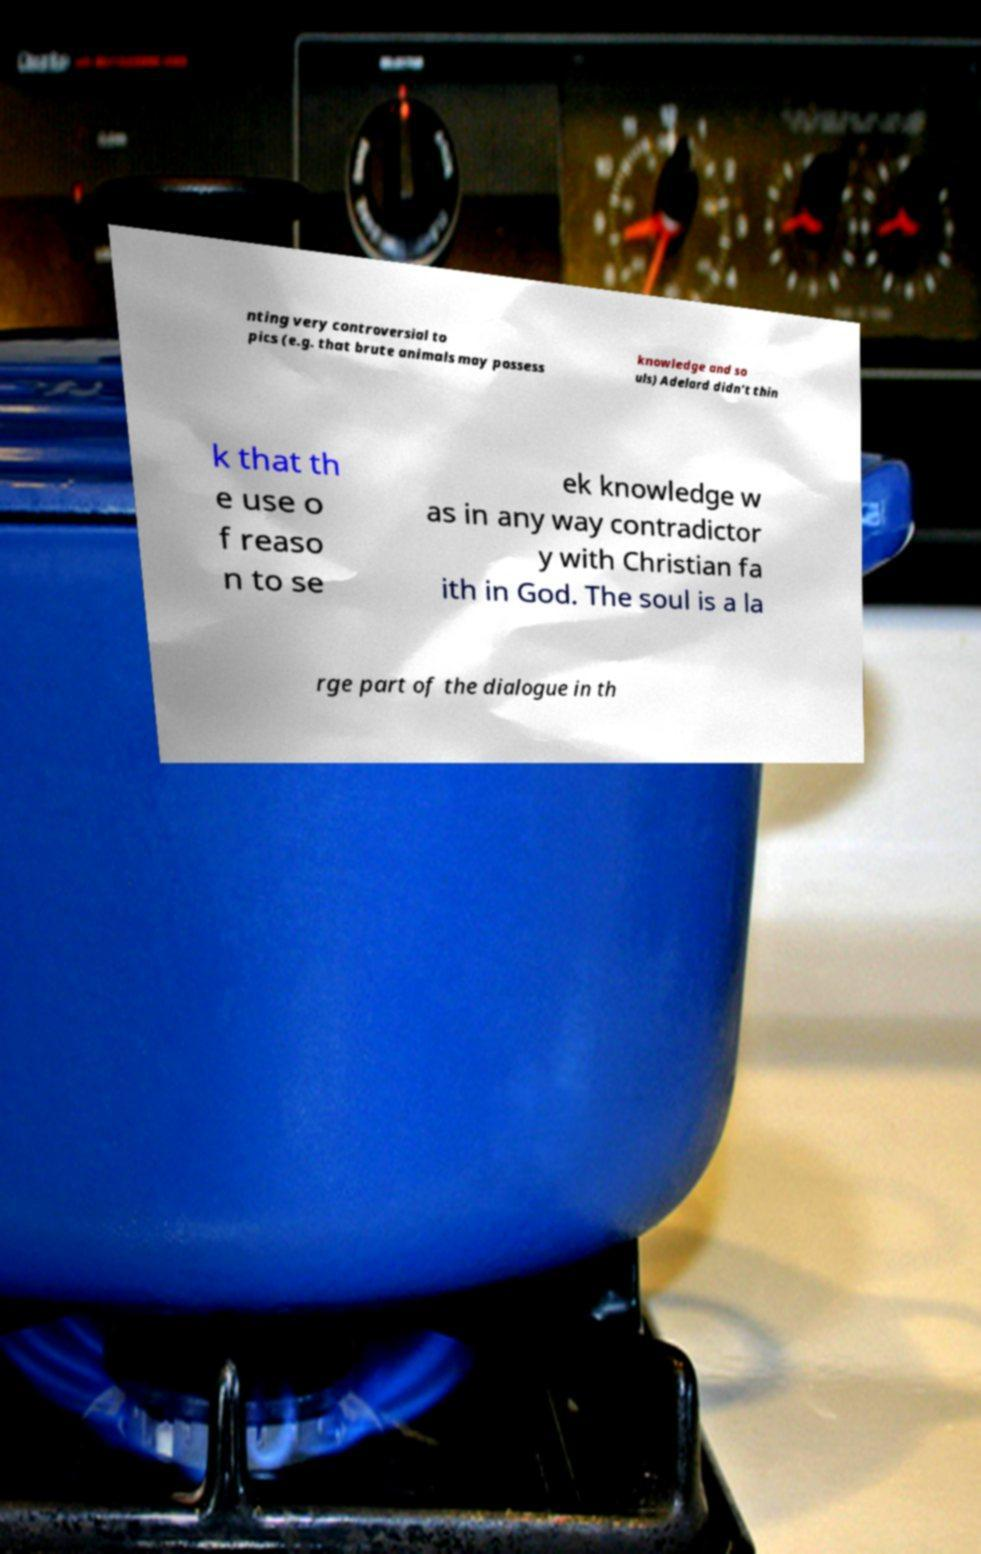For documentation purposes, I need the text within this image transcribed. Could you provide that? nting very controversial to pics (e.g. that brute animals may possess knowledge and so uls) Adelard didn't thin k that th e use o f reaso n to se ek knowledge w as in any way contradictor y with Christian fa ith in God. The soul is a la rge part of the dialogue in th 